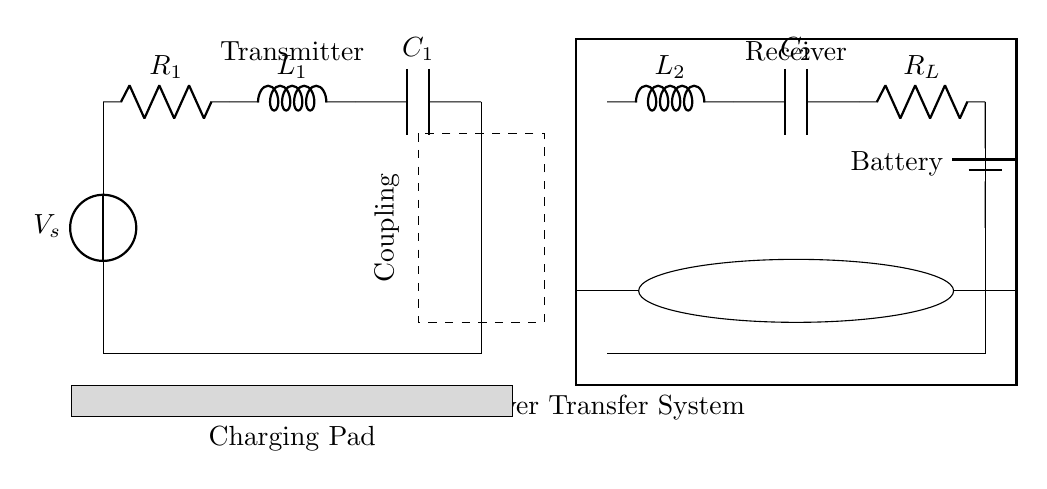What type of circuit is depicted? The circuit is an inductive power transfer system designed for wireless charging. It consists of a transmitter and a receiver.
Answer: Inductive power transfer system What is the purpose of the coupling? The coupling serves to transfer energy between the primary and secondary inductors through electromagnetic induction.
Answer: Transfer energy How many resistors are in the circuit? There are two resistors present, R1 on the transmitter side and R_L on the receiver side.
Answer: Two What element connects the battery to the load? The element that connects the battery to the load is the resistor R_L. This allows for current flow to the load from the battery.
Answer: Resistor R_L How is the vehicle encapsulated in the diagram? The vehicle is represented by a rectangular outline that encloses the transmitter and receiver components, indicating its boundary.
Answer: Rectangular outline What component is used to store energy in the transmitter? The component used to store energy in the transmitter is the capacitor C1, which is part of the resonant circuit.
Answer: Capacitor C1 Which side of the circuit contains the voltage source? The transmitter side contains the voltage source, labeled V_s, which provides the necessary power to the system.
Answer: Transmitter side 